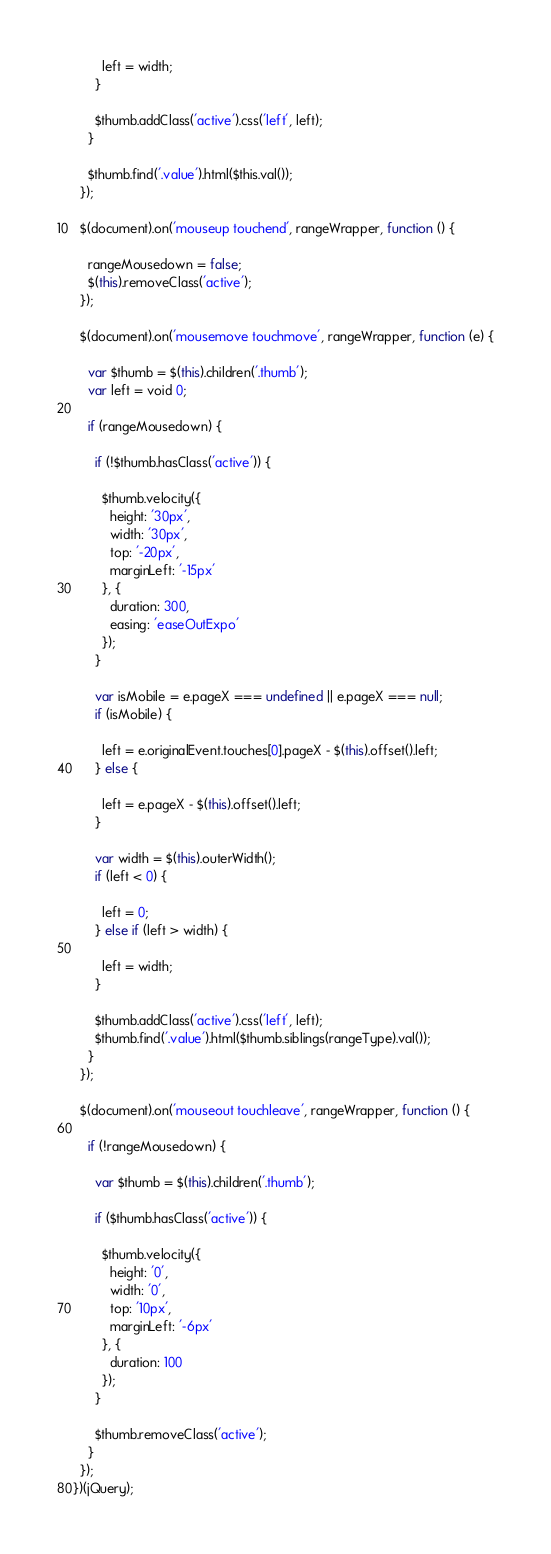Convert code to text. <code><loc_0><loc_0><loc_500><loc_500><_JavaScript_>
        left = width;
      }

      $thumb.addClass('active').css('left', left);
    }

    $thumb.find('.value').html($this.val());
  });

  $(document).on('mouseup touchend', rangeWrapper, function () {

    rangeMousedown = false;
    $(this).removeClass('active');
  });

  $(document).on('mousemove touchmove', rangeWrapper, function (e) {

    var $thumb = $(this).children('.thumb');
    var left = void 0;

    if (rangeMousedown) {

      if (!$thumb.hasClass('active')) {

        $thumb.velocity({
          height: '30px',
          width: '30px',
          top: '-20px',
          marginLeft: '-15px'
        }, {
          duration: 300,
          easing: 'easeOutExpo'
        });
      }

      var isMobile = e.pageX === undefined || e.pageX === null;
      if (isMobile) {

        left = e.originalEvent.touches[0].pageX - $(this).offset().left;
      } else {

        left = e.pageX - $(this).offset().left;
      }

      var width = $(this).outerWidth();
      if (left < 0) {

        left = 0;
      } else if (left > width) {

        left = width;
      }

      $thumb.addClass('active').css('left', left);
      $thumb.find('.value').html($thumb.siblings(rangeType).val());
    }
  });

  $(document).on('mouseout touchleave', rangeWrapper, function () {

    if (!rangeMousedown) {

      var $thumb = $(this).children('.thumb');

      if ($thumb.hasClass('active')) {

        $thumb.velocity({
          height: '0',
          width: '0',
          top: '10px',
          marginLeft: '-6px'
        }, {
          duration: 100
        });
      }

      $thumb.removeClass('active');
    }
  });
})(jQuery);</code> 